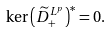<formula> <loc_0><loc_0><loc_500><loc_500>\ker \left ( \widetilde { D } ^ { L ^ { p } } _ { + } \right ) ^ { * } = 0 .</formula> 